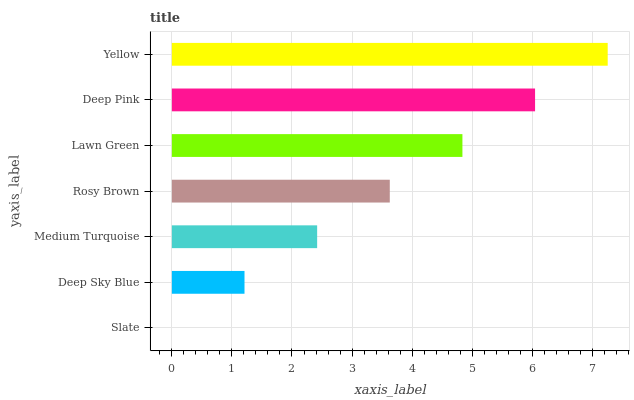Is Slate the minimum?
Answer yes or no. Yes. Is Yellow the maximum?
Answer yes or no. Yes. Is Deep Sky Blue the minimum?
Answer yes or no. No. Is Deep Sky Blue the maximum?
Answer yes or no. No. Is Deep Sky Blue greater than Slate?
Answer yes or no. Yes. Is Slate less than Deep Sky Blue?
Answer yes or no. Yes. Is Slate greater than Deep Sky Blue?
Answer yes or no. No. Is Deep Sky Blue less than Slate?
Answer yes or no. No. Is Rosy Brown the high median?
Answer yes or no. Yes. Is Rosy Brown the low median?
Answer yes or no. Yes. Is Yellow the high median?
Answer yes or no. No. Is Deep Pink the low median?
Answer yes or no. No. 